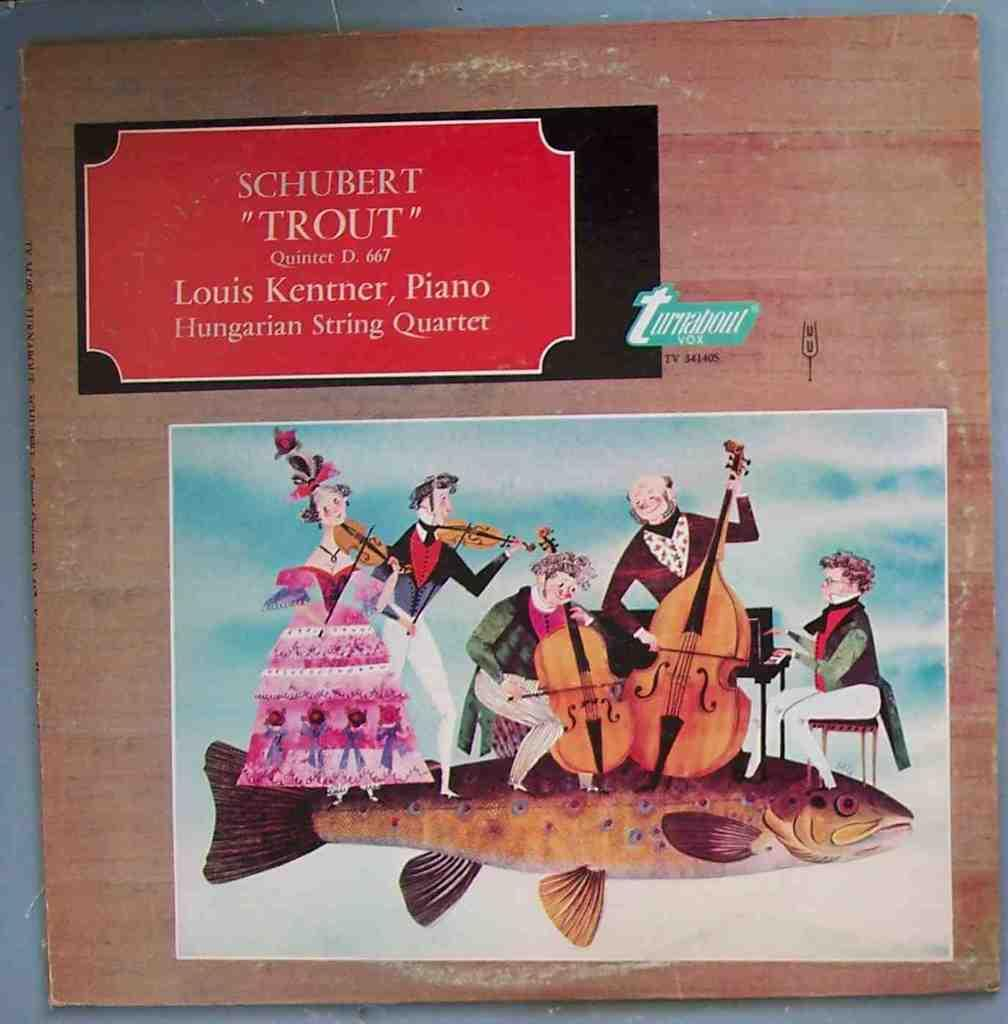<image>
Write a terse but informative summary of the picture. A piece of artwork labeled "Trout" Quintet hanging on a brown wall. 